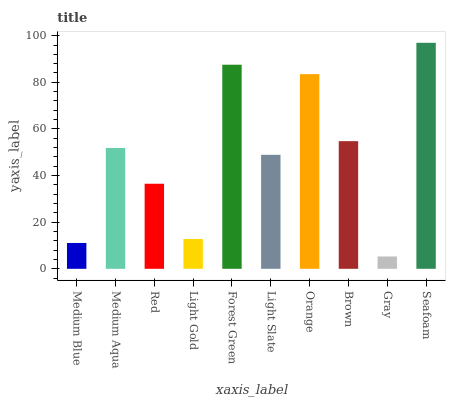Is Medium Aqua the minimum?
Answer yes or no. No. Is Medium Aqua the maximum?
Answer yes or no. No. Is Medium Aqua greater than Medium Blue?
Answer yes or no. Yes. Is Medium Blue less than Medium Aqua?
Answer yes or no. Yes. Is Medium Blue greater than Medium Aqua?
Answer yes or no. No. Is Medium Aqua less than Medium Blue?
Answer yes or no. No. Is Medium Aqua the high median?
Answer yes or no. Yes. Is Light Slate the low median?
Answer yes or no. Yes. Is Medium Blue the high median?
Answer yes or no. No. Is Seafoam the low median?
Answer yes or no. No. 